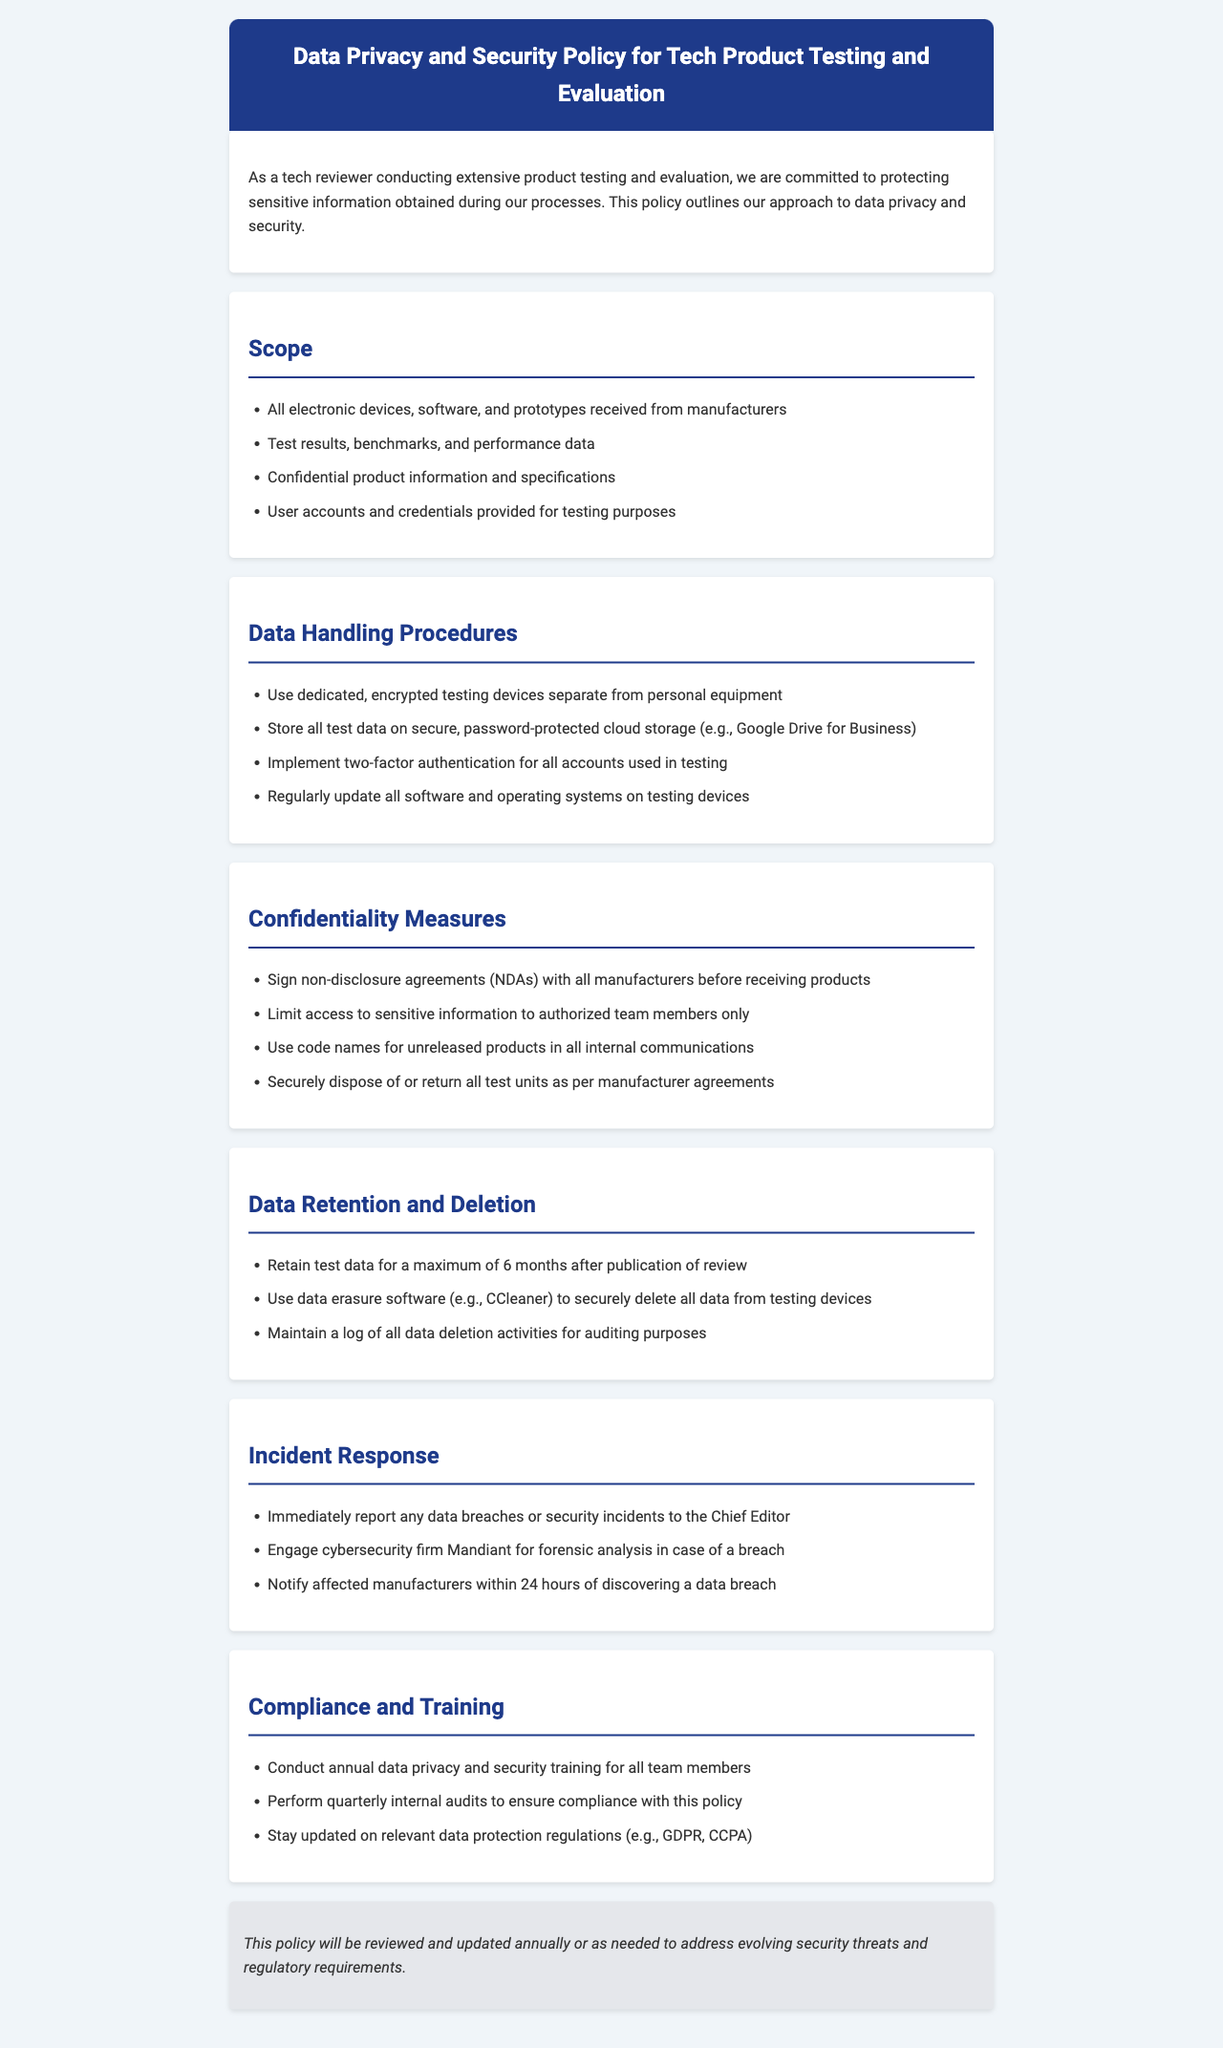What is the title of the document? The title of the document is found in the header section, stating the purpose of the policy document.
Answer: Data Privacy and Security Policy for Tech Product Testing and Evaluation What must be signed with manufacturers before receiving products? This refers to an agreement mentioned under the confidentiality measures that ensures sensitive information is protected.
Answer: Non-disclosure agreements (NDAs) What is the maximum retention period for test data after publication? This detail is specified in the data retention and deletion section of the document, outlining how long test data can be kept.
Answer: 6 months Who should be notified within 24 hours of a data breach? This information is contained in the incident response section, detailing the protocol for data breach notifications.
Answer: Affected manufacturers What cloud storage service is recommended for storing test data? The secure storage method mentioned in the data handling procedures indicates which cloud service should be used for data storage.
Answer: Google Drive for Business How often should internal audits be performed? This frequency is specified in the compliance and training section, addressing the regular compliance checks to be conducted.
Answer: Quarterly What security measure is implemented for accounts used in testing? This concerns the authentication method mentioned in the data handling procedures to secure access to sensitive information.
Answer: Two-factor authentication What company is engaged for forensic analysis in case of a breach? This detail is included in the incident response section, specifying the cybersecurity firm that may be involved during a breach.
Answer: Mandiant 